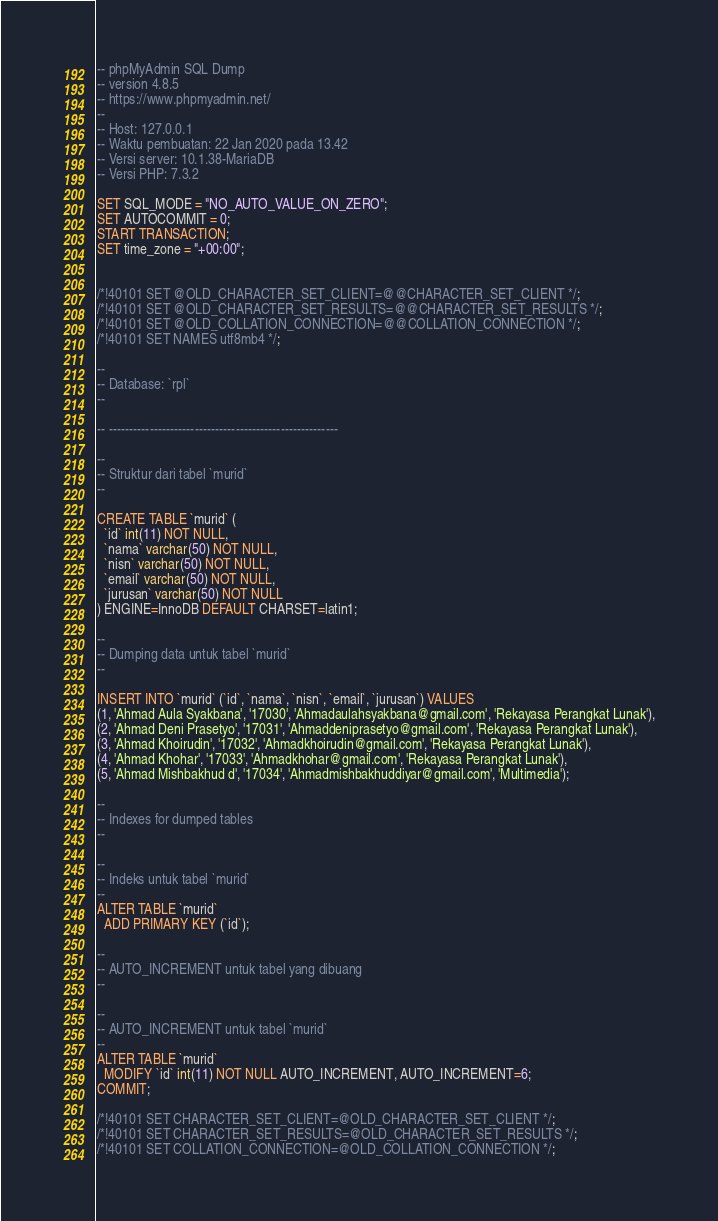<code> <loc_0><loc_0><loc_500><loc_500><_SQL_>-- phpMyAdmin SQL Dump
-- version 4.8.5
-- https://www.phpmyadmin.net/
--
-- Host: 127.0.0.1
-- Waktu pembuatan: 22 Jan 2020 pada 13.42
-- Versi server: 10.1.38-MariaDB
-- Versi PHP: 7.3.2

SET SQL_MODE = "NO_AUTO_VALUE_ON_ZERO";
SET AUTOCOMMIT = 0;
START TRANSACTION;
SET time_zone = "+00:00";


/*!40101 SET @OLD_CHARACTER_SET_CLIENT=@@CHARACTER_SET_CLIENT */;
/*!40101 SET @OLD_CHARACTER_SET_RESULTS=@@CHARACTER_SET_RESULTS */;
/*!40101 SET @OLD_COLLATION_CONNECTION=@@COLLATION_CONNECTION */;
/*!40101 SET NAMES utf8mb4 */;

--
-- Database: `rpl`
--

-- --------------------------------------------------------

--
-- Struktur dari tabel `murid`
--

CREATE TABLE `murid` (
  `id` int(11) NOT NULL,
  `nama` varchar(50) NOT NULL,
  `nisn` varchar(50) NOT NULL,
  `email` varchar(50) NOT NULL,
  `jurusan` varchar(50) NOT NULL
) ENGINE=InnoDB DEFAULT CHARSET=latin1;

--
-- Dumping data untuk tabel `murid`
--

INSERT INTO `murid` (`id`, `nama`, `nisn`, `email`, `jurusan`) VALUES
(1, 'Ahmad Aula Syakbana', '17030', 'Ahmadaulahsyakbana@gmail.com', 'Rekayasa Perangkat Lunak'),
(2, 'Ahmad Deni Prasetyo', '17031', 'Ahmaddeniprasetyo@gmail.com', 'Rekayasa Perangkat Lunak'),
(3, 'Ahmad Khoirudin', '17032', 'Ahmadkhoirudin@gmail.com', 'Rekayasa Perangkat Lunak'),
(4, 'Ahmad Khohar', '17033', 'Ahmadkhohar@gmail.com', 'Rekayasa Perangkat Lunak'),
(5, 'Ahmad Mishbakhud d', '17034', 'Ahmadmishbakhuddiyar@gmail.com', 'Multimedia');

--
-- Indexes for dumped tables
--

--
-- Indeks untuk tabel `murid`
--
ALTER TABLE `murid`
  ADD PRIMARY KEY (`id`);

--
-- AUTO_INCREMENT untuk tabel yang dibuang
--

--
-- AUTO_INCREMENT untuk tabel `murid`
--
ALTER TABLE `murid`
  MODIFY `id` int(11) NOT NULL AUTO_INCREMENT, AUTO_INCREMENT=6;
COMMIT;

/*!40101 SET CHARACTER_SET_CLIENT=@OLD_CHARACTER_SET_CLIENT */;
/*!40101 SET CHARACTER_SET_RESULTS=@OLD_CHARACTER_SET_RESULTS */;
/*!40101 SET COLLATION_CONNECTION=@OLD_COLLATION_CONNECTION */;
</code> 